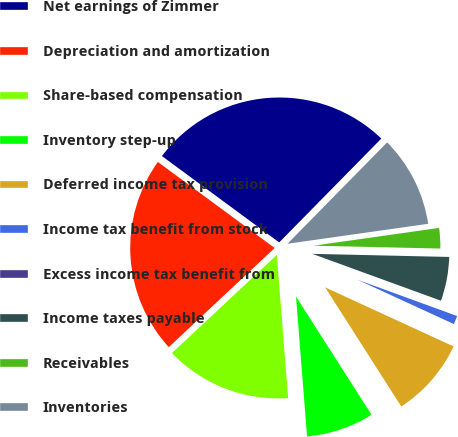<chart> <loc_0><loc_0><loc_500><loc_500><pie_chart><fcel>Net earnings of Zimmer<fcel>Depreciation and amortization<fcel>Share-based compensation<fcel>Inventory step-up<fcel>Deferred income tax provision<fcel>Income tax benefit from stock<fcel>Excess income tax benefit from<fcel>Income taxes payable<fcel>Receivables<fcel>Inventories<nl><fcel>27.26%<fcel>22.07%<fcel>14.28%<fcel>7.79%<fcel>9.09%<fcel>1.3%<fcel>0.0%<fcel>5.2%<fcel>2.6%<fcel>10.39%<nl></chart> 